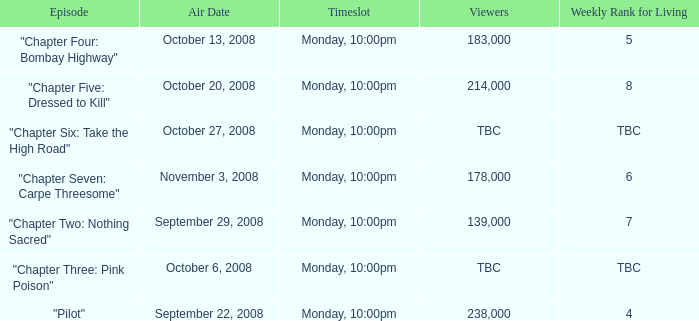What is the episode with the 183,000 viewers? "Chapter Four: Bombay Highway". 